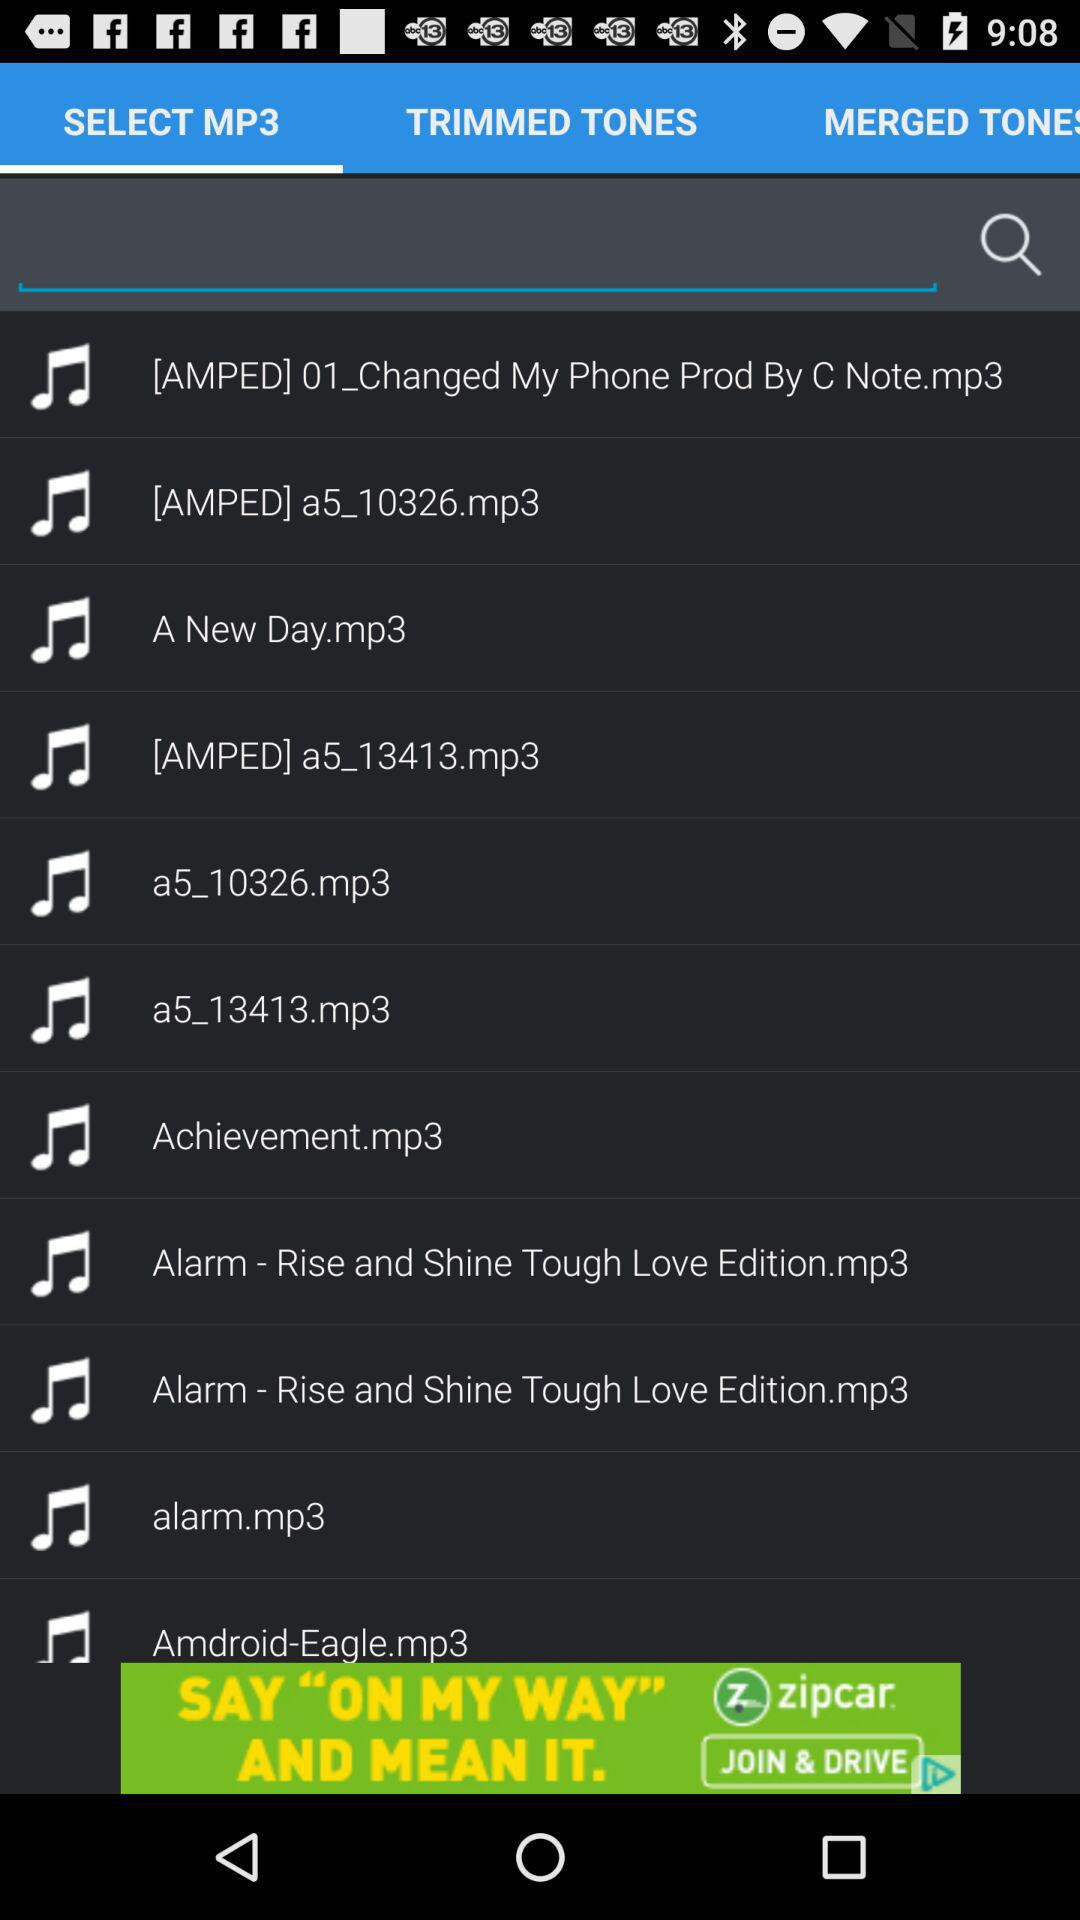Which option has been selected? The selected option is "SELECT MP3". 